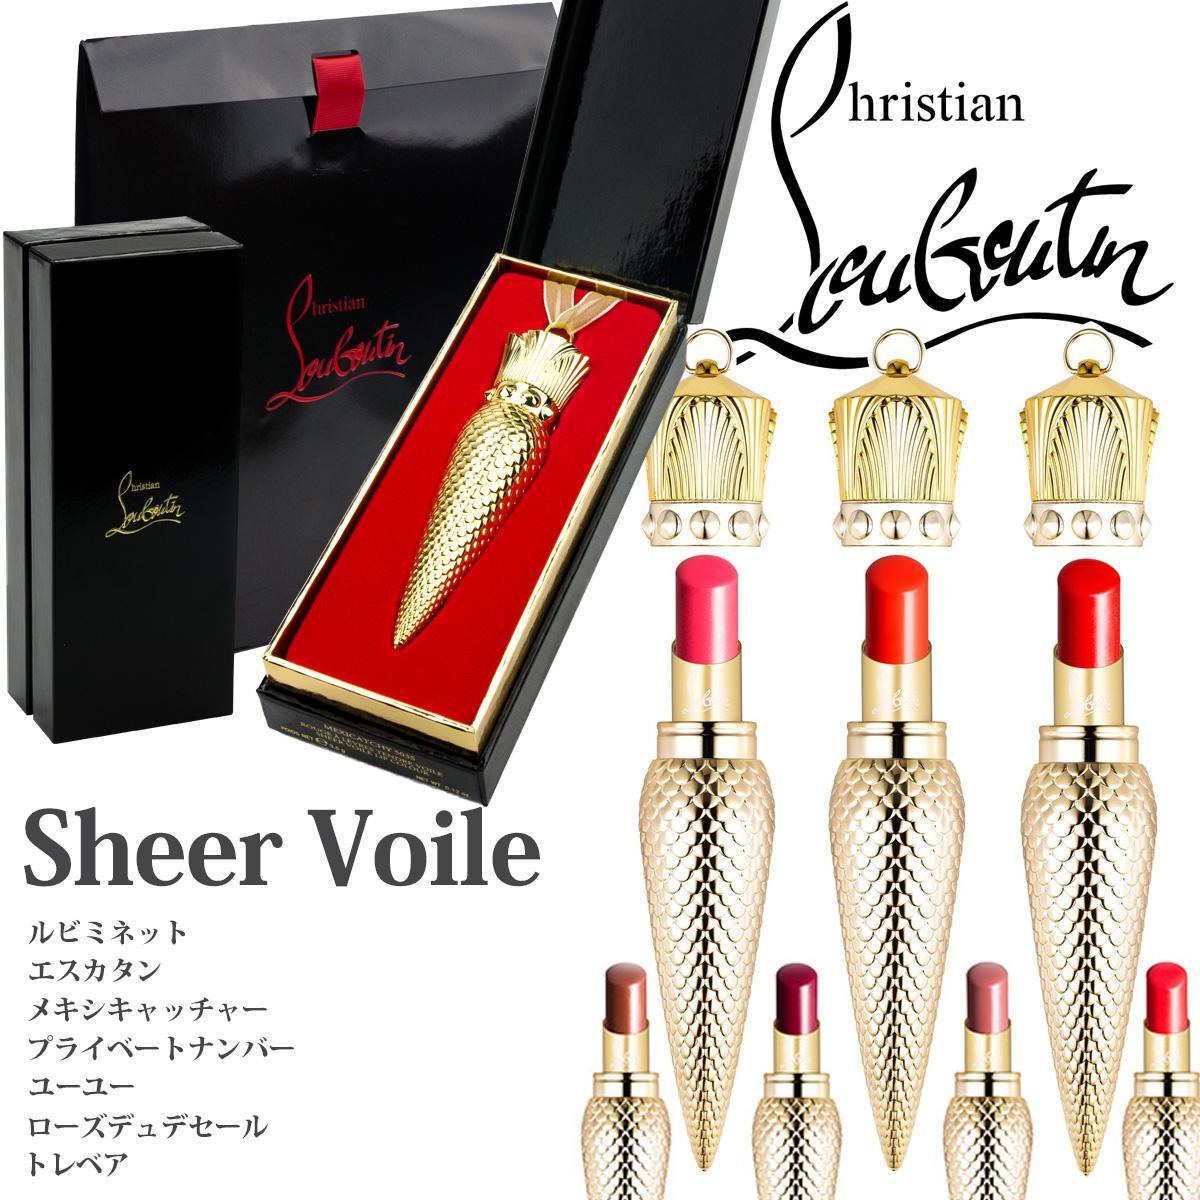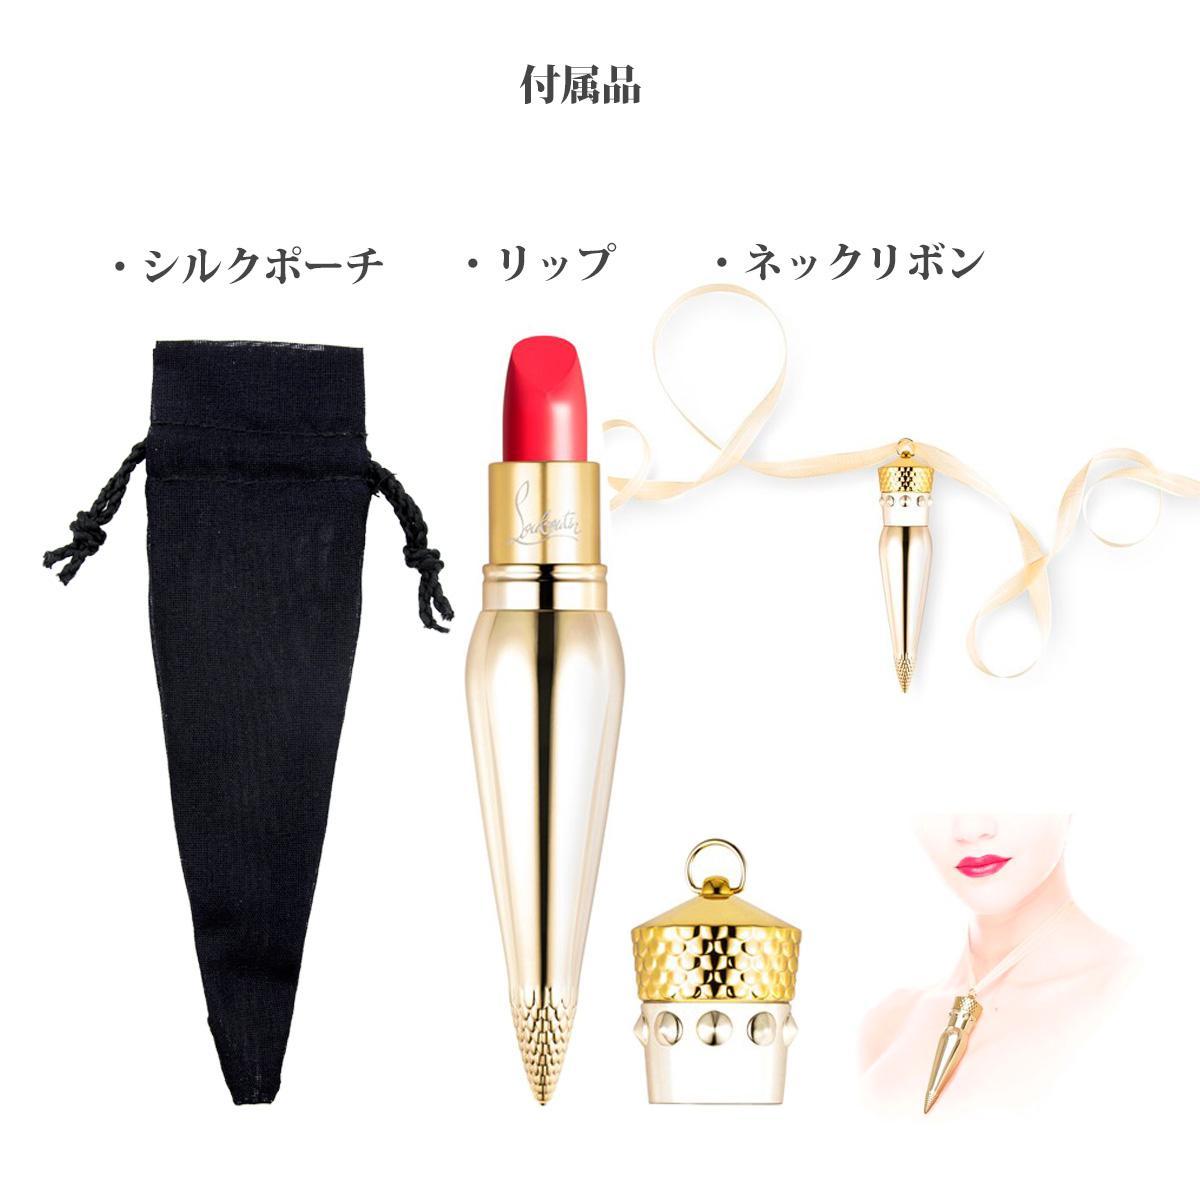The first image is the image on the left, the second image is the image on the right. Examine the images to the left and right. Is the description "One vial of cone shaped lip gloss is shown in one of the images while more are shown in the other." accurate? Answer yes or no. Yes. The first image is the image on the left, the second image is the image on the right. Analyze the images presented: Is the assertion "An image shows eight different makeup shades in tapered decorative containers, displayed scattered instead of in rows." valid? Answer yes or no. No. 